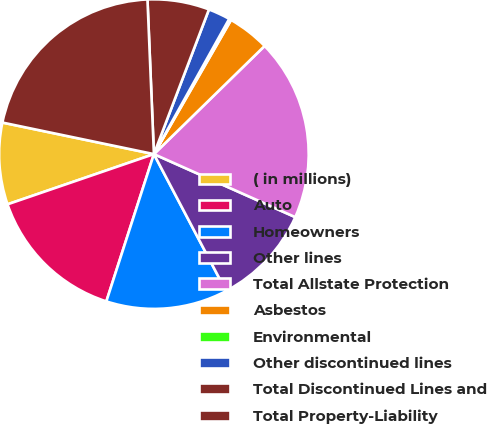Convert chart. <chart><loc_0><loc_0><loc_500><loc_500><pie_chart><fcel>( in millions)<fcel>Auto<fcel>Homeowners<fcel>Other lines<fcel>Total Allstate Protection<fcel>Asbestos<fcel>Environmental<fcel>Other discontinued lines<fcel>Total Discontinued Lines and<fcel>Total Property-Liability<nl><fcel>8.53%<fcel>14.77%<fcel>12.69%<fcel>10.61%<fcel>18.99%<fcel>4.38%<fcel>0.22%<fcel>2.3%<fcel>6.45%<fcel>21.07%<nl></chart> 